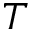Convert formula to latex. <formula><loc_0><loc_0><loc_500><loc_500>T</formula> 